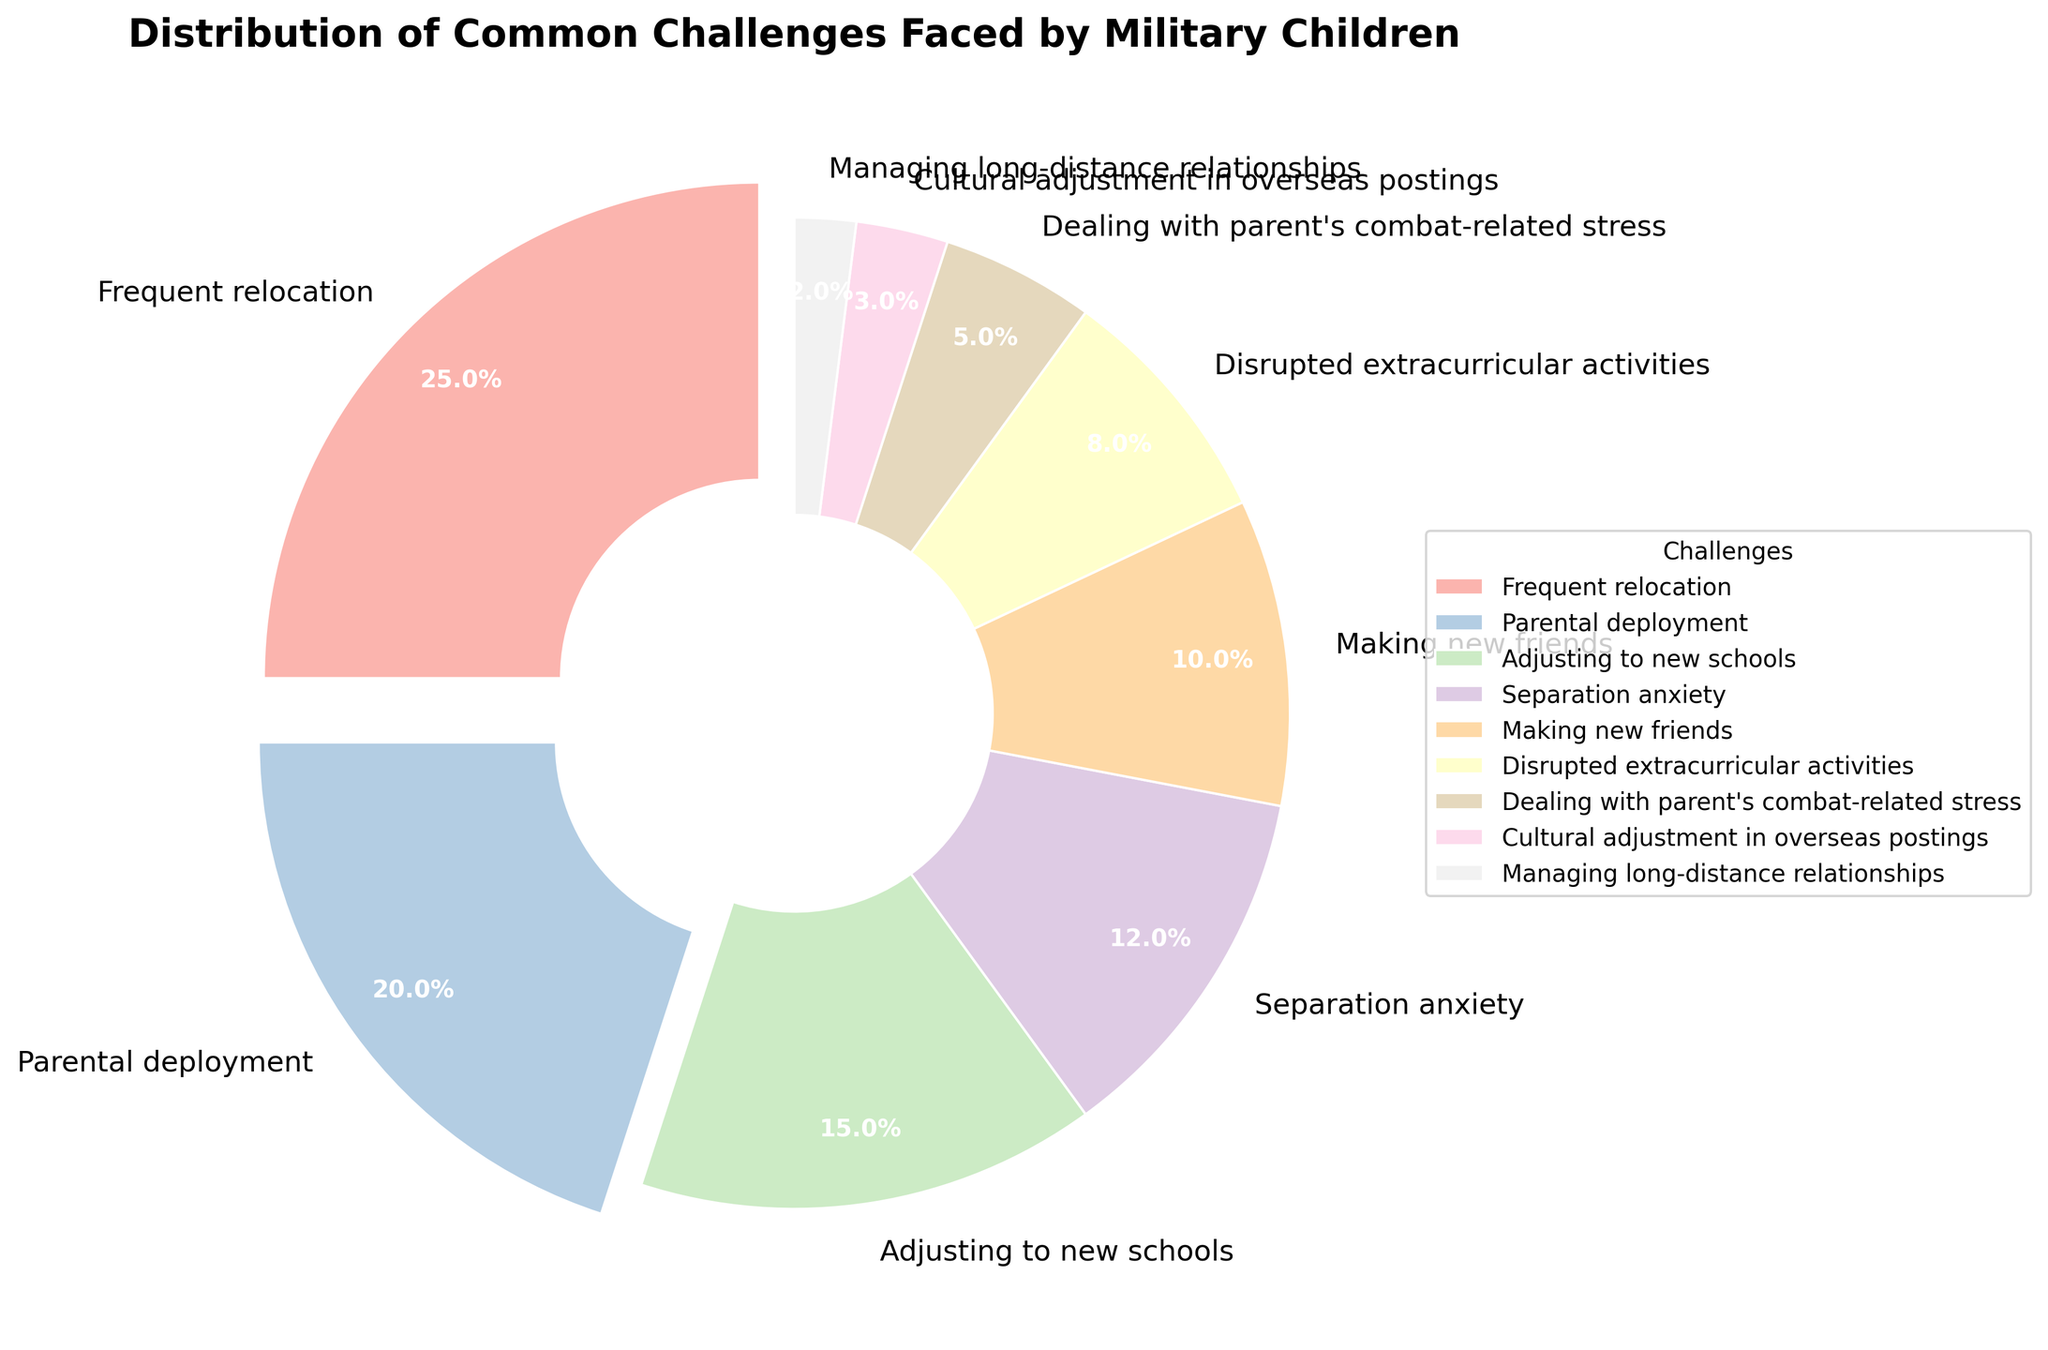What's the largest challenge faced by military children? The largest challenge can be identified as the segment with the highest percentage. "Frequent relocation" is marked prominently and takes up the biggest slice of the pie chart.
Answer: Frequent relocation How many challenges account for 60% of the total? To find out how many challenges make up 60%, add the percentages in a descending order until the sum first exceeds 60%. The challenges "Frequent relocation" (25%), "Parental deployment" (20%), and "Adjusting to new schools" (15%) add up to 60%.
Answer: 3 Which challenge has the closest percentage to "Adjusting to new schools"? "Adjusting to new schools" has a percentage of 15%. The challenge with the closest percentage is "Parental deployment" at 20%.
Answer: Parental deployment Which challenges have a percentage less than 10%? Challenges that have a percentage less than 10% can be identified by their smaller pie segments. These include "Disrupted extracurricular activities" (8%), "Dealing with parent's combat-related stress" (5%), "Cultural adjustment in overseas postings" (3%), and "Managing long-distance relationships" (2%).
Answer: Disrupted extracurricular activities, Dealing with parent's combat-related stress, Cultural adjustment in overseas postings, Managing long-distance relationships How much more percentage does "Frequent relocation" have compared to "Making new friends"? Subtract the percentage for "Making new friends" (10%) from "Frequent relocation" (25%). The difference is 15%.
Answer: 15% What is the total percentage of challenges related to social aspects (Adjusting to new schools and Making new friends)? Add the percentages of "Adjusting to new schools" (15%) and "Making new friends" (10%). The total is 25%.
Answer: 25% Compare the percentages of "Separation anxiety" and "Parental deployment". Which is higher? Look at the pie chart segments for "Separation anxiety" (12%) and "Parental deployment" (20%). "Parental deployment" is higher.
Answer: Parental deployment Which challenge occupies the smallest portion of the pie chart? Identify the smallest segment of the pie chart which corresponds to "Managing long-distance relationships" marked at 2%.
Answer: Managing long-distance relationships 